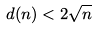<formula> <loc_0><loc_0><loc_500><loc_500>d ( n ) < 2 \sqrt { n }</formula> 